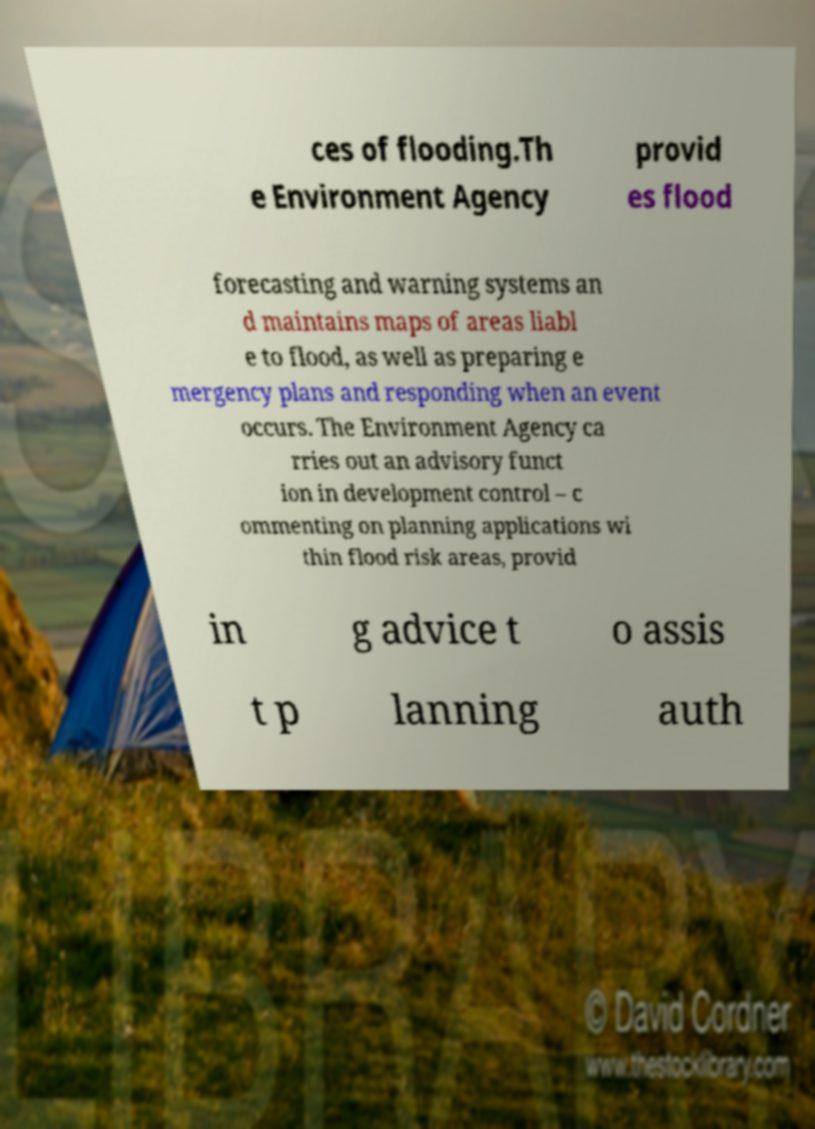Can you read and provide the text displayed in the image?This photo seems to have some interesting text. Can you extract and type it out for me? ces of flooding.Th e Environment Agency provid es flood forecasting and warning systems an d maintains maps of areas liabl e to flood, as well as preparing e mergency plans and responding when an event occurs. The Environment Agency ca rries out an advisory funct ion in development control – c ommenting on planning applications wi thin flood risk areas, provid in g advice t o assis t p lanning auth 